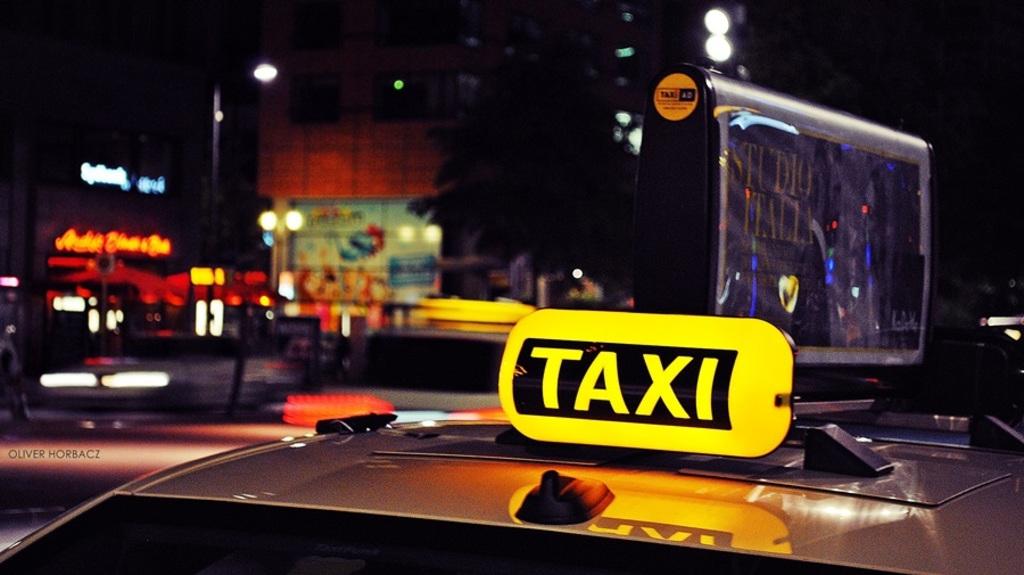What kind of vehicle is this?
Provide a short and direct response. Taxi. What does the taxi advertise on sign?
Provide a short and direct response. Taxi. 